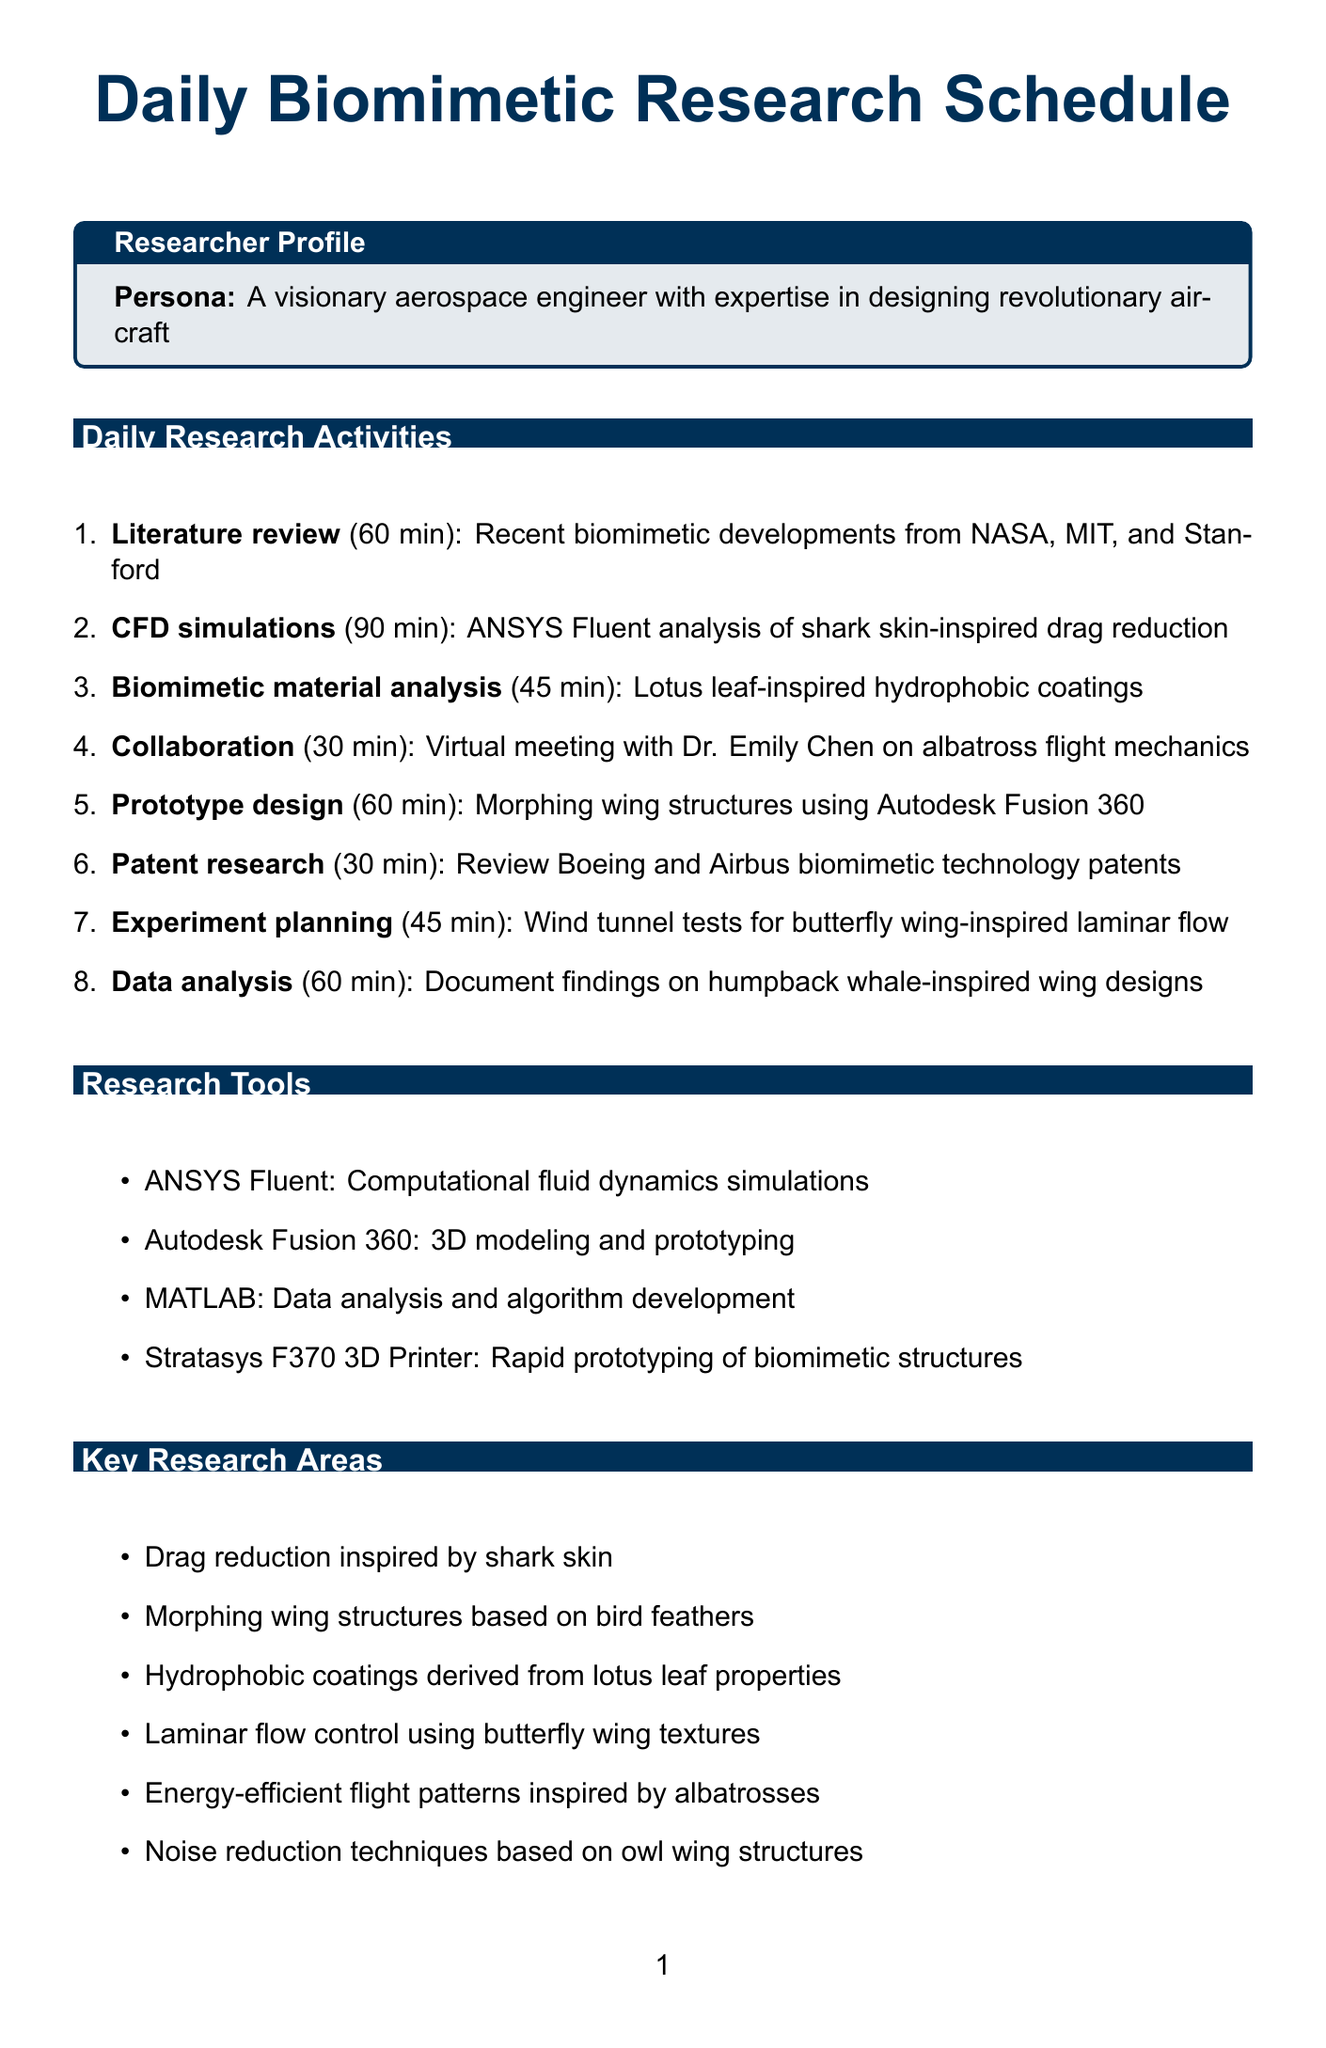What is the total duration of literature review? The document states that the literature review activity lasts for 60 minutes.
Answer: 60 minutes Who is collaborating with the researcher from Harvard University? The document specifies that Dr. Emily Chen is the collaborator from Harvard University.
Answer: Dr. Emily Chen What is the purpose of ANSYS Fluent? The document states that ANSYS Fluent is used for computational fluid dynamics simulations.
Answer: Computational fluid dynamics simulations How long is the activity for CFD simulations? The document indicates that the CFD simulations activity lasts for 90 minutes.
Answer: 90 minutes What is one of the key research areas related to drag reduction? The document lists drag reduction inspired by shark skin as a key research area.
Answer: Drag reduction inspired by shark skin What tool is used for 3D modeling and prototyping? The document mentions Autodesk Fusion 360 as the tool for 3D modeling and prototyping.
Answer: Autodesk Fusion 360 How long is the experimental setup planning activity? The document specifies that the experimental setup planning activity takes 45 minutes.
Answer: 45 minutes Which company is working on biomimetic coatings for aircraft? The document states that Boeing is focused on biomimetic coatings for next-generation commercial aircraft.
Answer: Boeing 